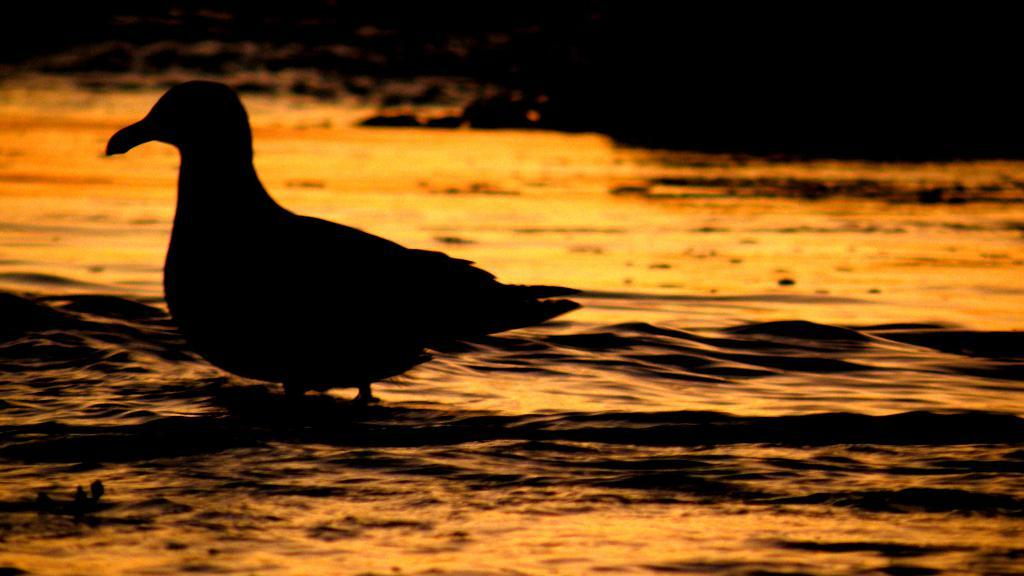What type of animal is in the image? There is a bird in the image. Where is the bird located? The bird is on water. What can be observed about the background of the image? The background of the image is dark. What division of the company does the bird represent in the image? There is no indication in the image that the bird represents any division of a company. 